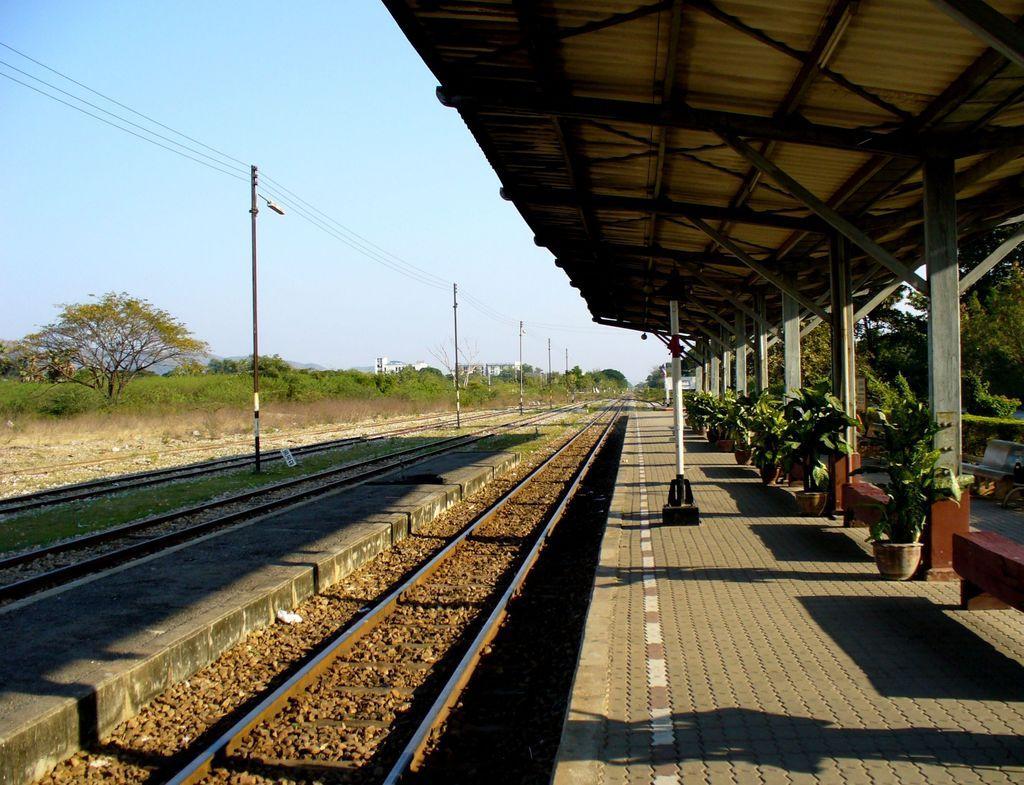Could you give a brief overview of what you see in this image? This image is clicked at a railway station. To the left the railway there are railway tracks on the ground. There are poles and grass on the ground beside the tracks. To the right there is a platform. There is a shed on the platform. There are benches and flower pots on the floor. In the background there are trees and buildings. At the top there is the sky. 